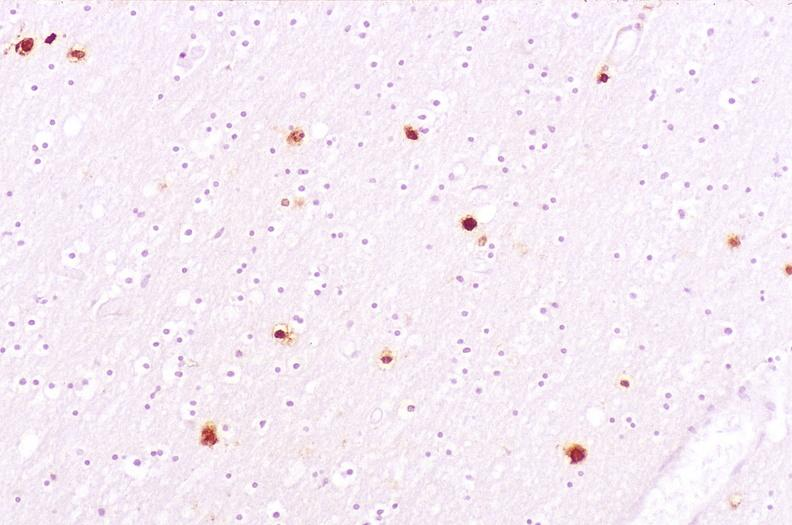s nervous present?
Answer the question using a single word or phrase. Yes 